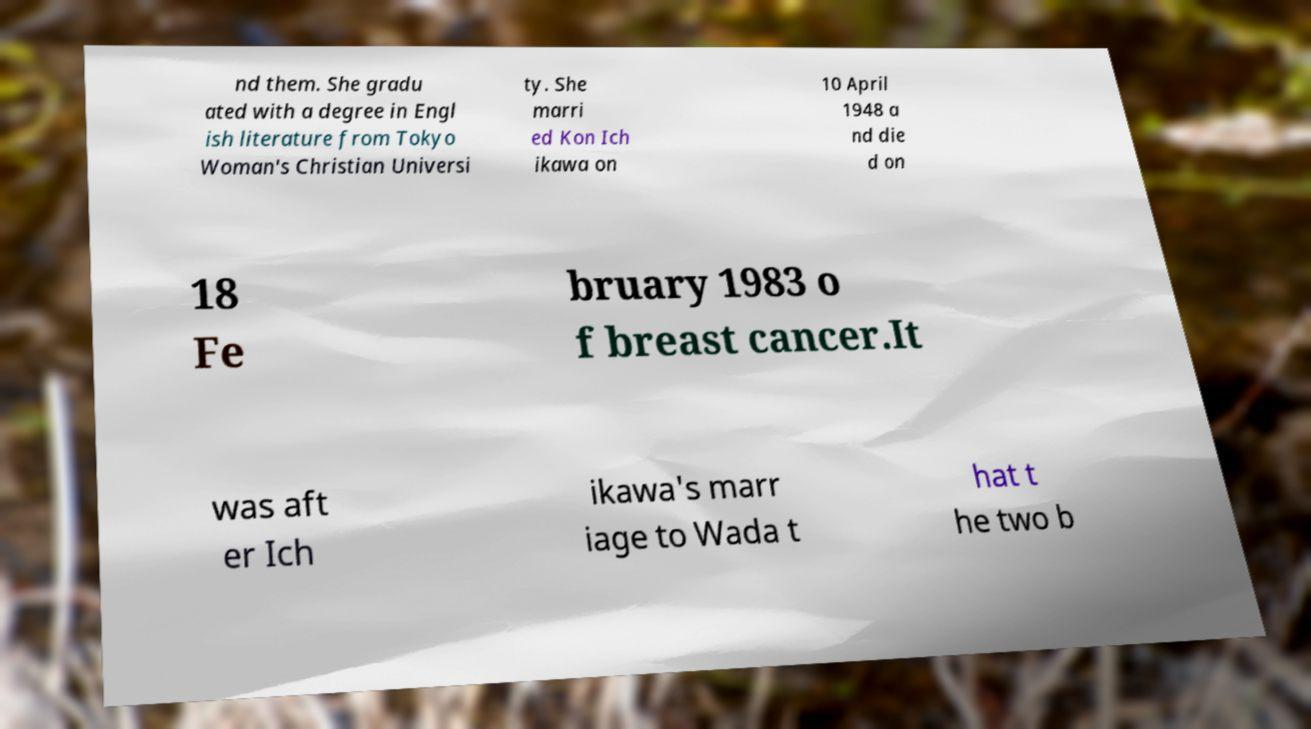Could you extract and type out the text from this image? nd them. She gradu ated with a degree in Engl ish literature from Tokyo Woman's Christian Universi ty. She marri ed Kon Ich ikawa on 10 April 1948 a nd die d on 18 Fe bruary 1983 o f breast cancer.It was aft er Ich ikawa's marr iage to Wada t hat t he two b 